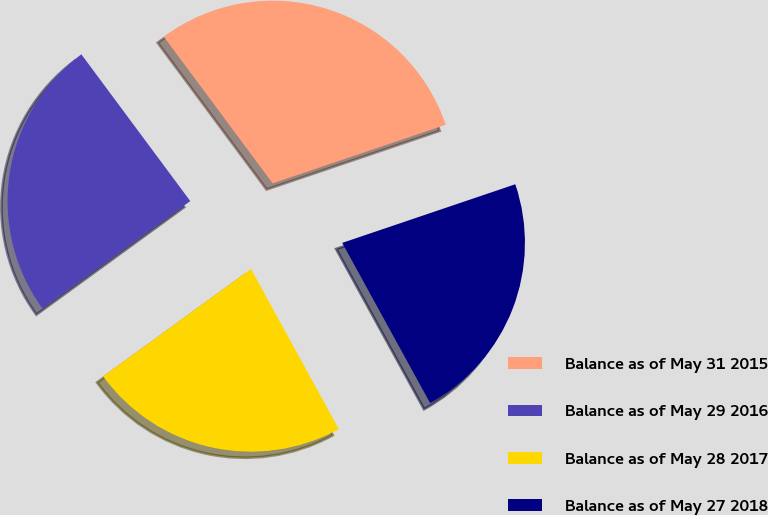<chart> <loc_0><loc_0><loc_500><loc_500><pie_chart><fcel>Balance as of May 31 2015<fcel>Balance as of May 29 2016<fcel>Balance as of May 28 2017<fcel>Balance as of May 27 2018<nl><fcel>29.96%<fcel>24.84%<fcel>22.98%<fcel>22.21%<nl></chart> 